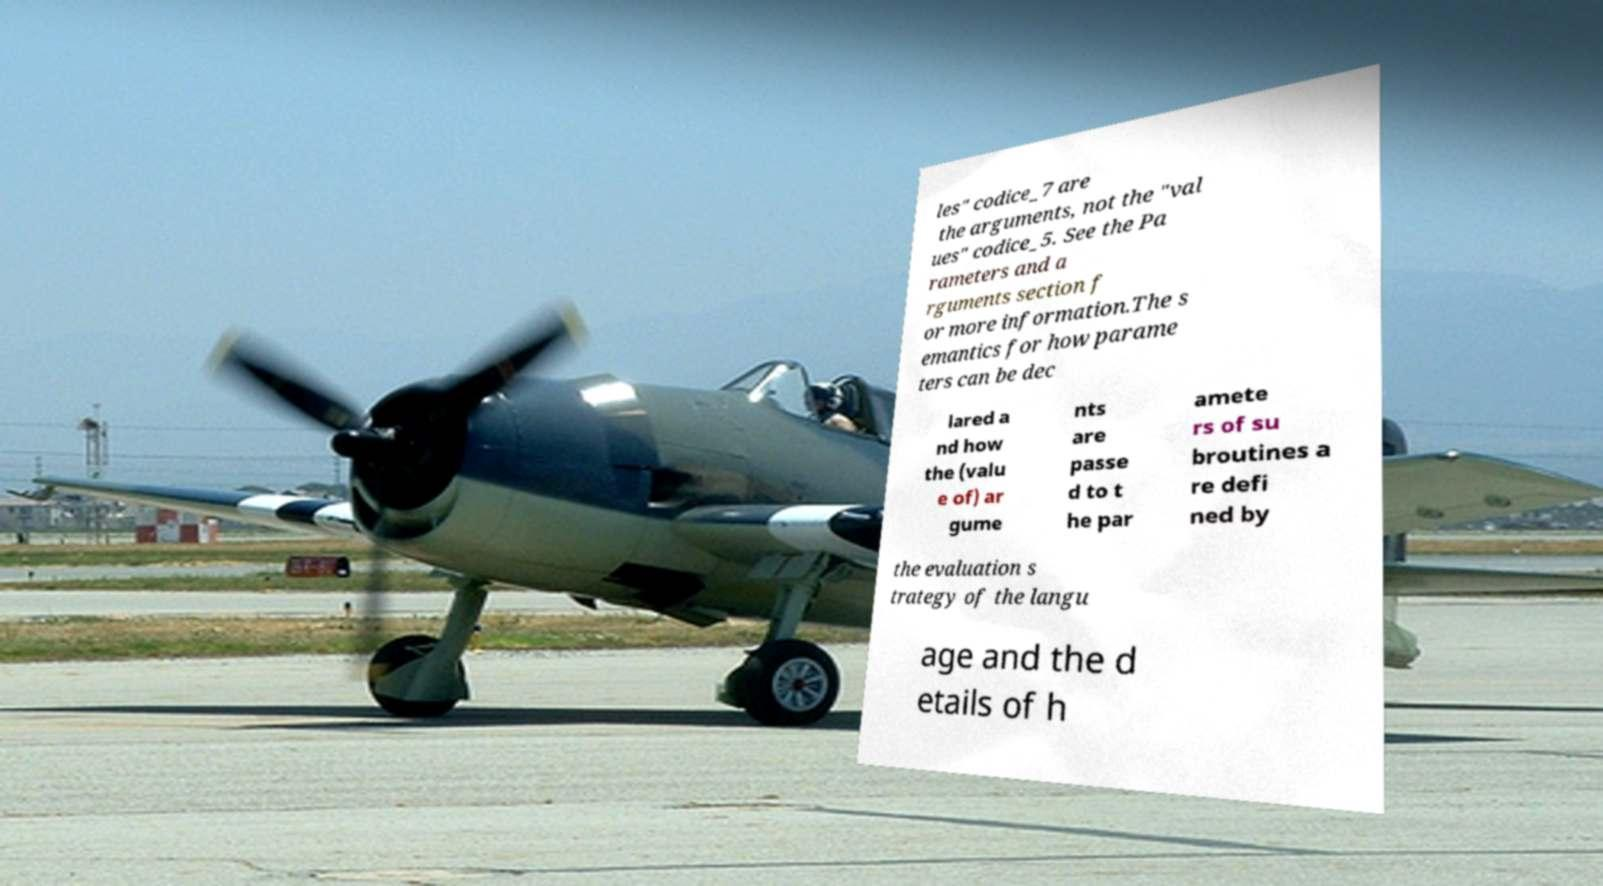For documentation purposes, I need the text within this image transcribed. Could you provide that? les" codice_7 are the arguments, not the "val ues" codice_5. See the Pa rameters and a rguments section f or more information.The s emantics for how parame ters can be dec lared a nd how the (valu e of) ar gume nts are passe d to t he par amete rs of su broutines a re defi ned by the evaluation s trategy of the langu age and the d etails of h 